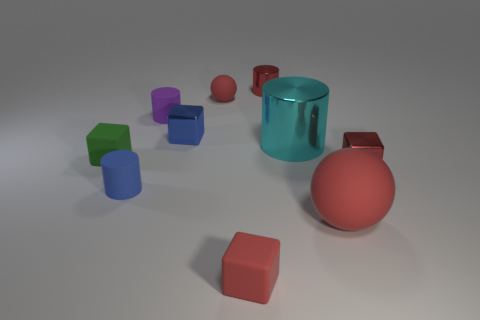Subtract 1 blocks. How many blocks are left? 3 Subtract all blocks. How many objects are left? 6 Add 1 cyan metallic things. How many cyan metallic things are left? 2 Add 6 cyan metallic things. How many cyan metallic things exist? 7 Subtract 1 green blocks. How many objects are left? 9 Subtract all tiny cylinders. Subtract all small red rubber spheres. How many objects are left? 6 